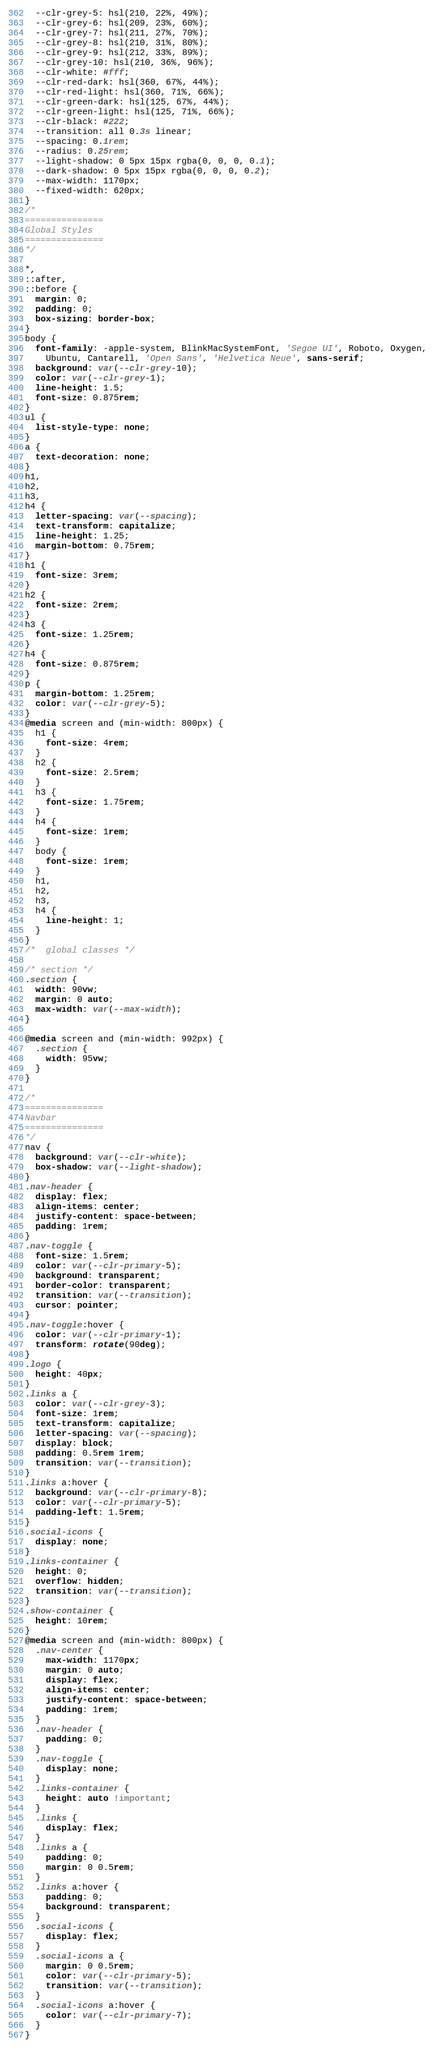<code> <loc_0><loc_0><loc_500><loc_500><_CSS_>  --clr-grey-5: hsl(210, 22%, 49%);
  --clr-grey-6: hsl(209, 23%, 60%);
  --clr-grey-7: hsl(211, 27%, 70%);
  --clr-grey-8: hsl(210, 31%, 80%);
  --clr-grey-9: hsl(212, 33%, 89%);
  --clr-grey-10: hsl(210, 36%, 96%);
  --clr-white: #fff;
  --clr-red-dark: hsl(360, 67%, 44%);
  --clr-red-light: hsl(360, 71%, 66%);
  --clr-green-dark: hsl(125, 67%, 44%);
  --clr-green-light: hsl(125, 71%, 66%);
  --clr-black: #222;
  --transition: all 0.3s linear;
  --spacing: 0.1rem;
  --radius: 0.25rem;
  --light-shadow: 0 5px 15px rgba(0, 0, 0, 0.1);
  --dark-shadow: 0 5px 15px rgba(0, 0, 0, 0.2);
  --max-width: 1170px;
  --fixed-width: 620px;
}
/*
=============== 
Global Styles
===============
*/

*,
::after,
::before {
  margin: 0;
  padding: 0;
  box-sizing: border-box;
}
body {
  font-family: -apple-system, BlinkMacSystemFont, 'Segoe UI', Roboto, Oxygen,
    Ubuntu, Cantarell, 'Open Sans', 'Helvetica Neue', sans-serif;
  background: var(--clr-grey-10);
  color: var(--clr-grey-1);
  line-height: 1.5;
  font-size: 0.875rem;
}
ul {
  list-style-type: none;
}
a {
  text-decoration: none;
}
h1,
h2,
h3,
h4 {
  letter-spacing: var(--spacing);
  text-transform: capitalize;
  line-height: 1.25;
  margin-bottom: 0.75rem;
}
h1 {
  font-size: 3rem;
}
h2 {
  font-size: 2rem;
}
h3 {
  font-size: 1.25rem;
}
h4 {
  font-size: 0.875rem;
}
p {
  margin-bottom: 1.25rem;
  color: var(--clr-grey-5);
}
@media screen and (min-width: 800px) {
  h1 {
    font-size: 4rem;
  }
  h2 {
    font-size: 2.5rem;
  }
  h3 {
    font-size: 1.75rem;
  }
  h4 {
    font-size: 1rem;
  }
  body {
    font-size: 1rem;
  }
  h1,
  h2,
  h3,
  h4 {
    line-height: 1;
  }
}
/*  global classes */

/* section */
.section {
  width: 90vw;
  margin: 0 auto;
  max-width: var(--max-width);
}

@media screen and (min-width: 992px) {
  .section {
    width: 95vw;
  }
}

/*
=============== 
Navbar
===============
*/
nav {
  background: var(--clr-white);
  box-shadow: var(--light-shadow);
}
.nav-header {
  display: flex;
  align-items: center;
  justify-content: space-between;
  padding: 1rem;
}
.nav-toggle {
  font-size: 1.5rem;
  color: var(--clr-primary-5);
  background: transparent;
  border-color: transparent;
  transition: var(--transition);
  cursor: pointer;
}
.nav-toggle:hover {
  color: var(--clr-primary-1);
  transform: rotate(90deg);
}
.logo {
  height: 40px;
}
.links a {
  color: var(--clr-grey-3);
  font-size: 1rem;
  text-transform: capitalize;
  letter-spacing: var(--spacing);
  display: block;
  padding: 0.5rem 1rem;
  transition: var(--transition);
}
.links a:hover {
  background: var(--clr-primary-8);
  color: var(--clr-primary-5);
  padding-left: 1.5rem;
}
.social-icons {
  display: none;
}
.links-container {
  height: 0;
  overflow: hidden;
  transition: var(--transition);
}
.show-container {
  height: 10rem;
}
@media screen and (min-width: 800px) {
  .nav-center {
    max-width: 1170px;
    margin: 0 auto;
    display: flex;
    align-items: center;
    justify-content: space-between;
    padding: 1rem;
  }
  .nav-header {
    padding: 0;
  }
  .nav-toggle {
    display: none;
  }
  .links-container {
    height: auto !important;
  }
  .links {
    display: flex;
  }
  .links a {
    padding: 0;
    margin: 0 0.5rem;
  }
  .links a:hover {
    padding: 0;
    background: transparent;
  }
  .social-icons {
    display: flex;
  }
  .social-icons a {
    margin: 0 0.5rem;
    color: var(--clr-primary-5);
    transition: var(--transition);
  }
  .social-icons a:hover {
    color: var(--clr-primary-7);
  }
}
</code> 